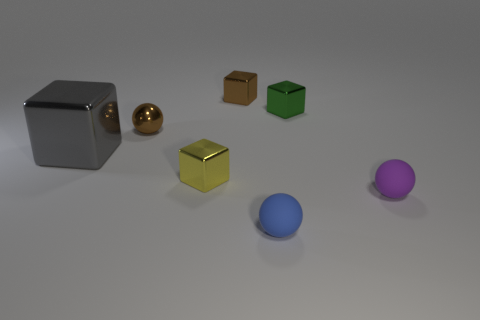The small sphere that is both in front of the gray metallic object and on the left side of the small green shiny cube is made of what material?
Offer a very short reply. Rubber. Do the sphere that is behind the gray object and the tiny sphere that is to the right of the green object have the same material?
Your answer should be very brief. No. The brown shiny block is what size?
Your answer should be compact. Small. There is a brown object that is the same shape as the small green shiny object; what is its size?
Provide a succinct answer. Small. There is a tiny brown shiny block; what number of tiny blue matte objects are in front of it?
Offer a terse response. 1. What color is the tiny metal cube that is in front of the small brown thing that is in front of the brown shiny cube?
Offer a very short reply. Yellow. Is there anything else that has the same shape as the small blue object?
Provide a short and direct response. Yes. Are there an equal number of purple rubber objects that are right of the tiny purple sphere and small spheres to the right of the big gray shiny block?
Provide a short and direct response. No. What number of cubes are small yellow metallic things or big gray metal objects?
Provide a short and direct response. 2. How many other things are made of the same material as the small yellow object?
Ensure brevity in your answer.  4. 